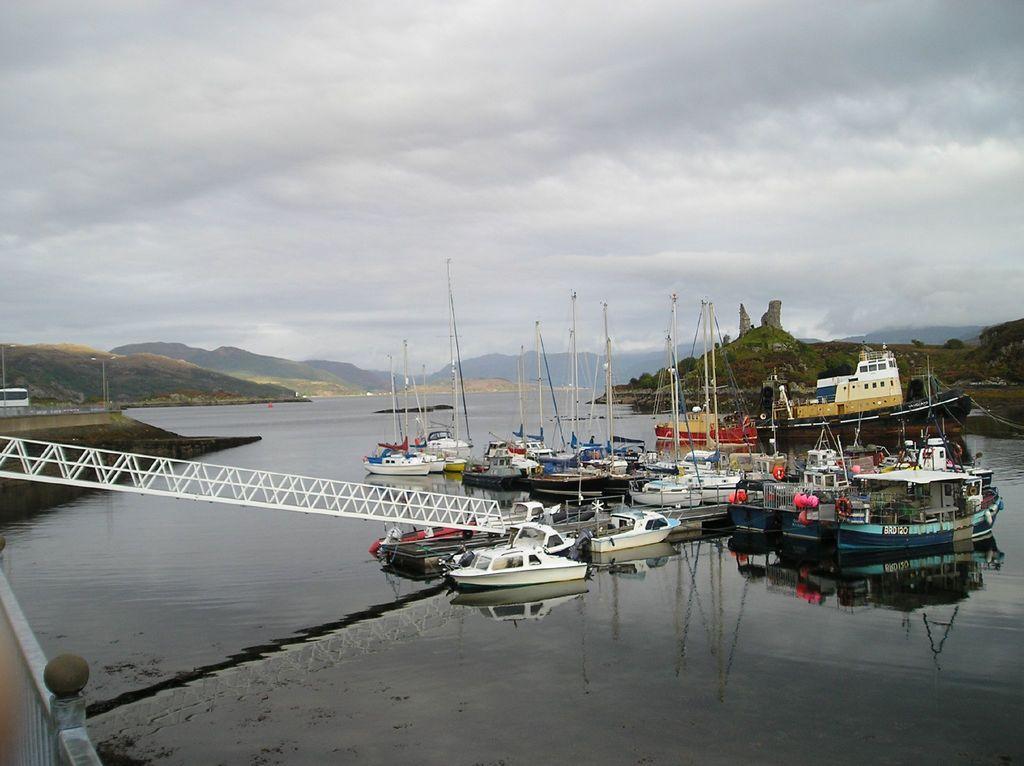Can you describe this image briefly? In this image I can see a lake , on the lake I can see ships and in the bottom left I can see the wall ,at the top I can see the sky and in the middle I can see the hill and there is a stand visible on the left side. 